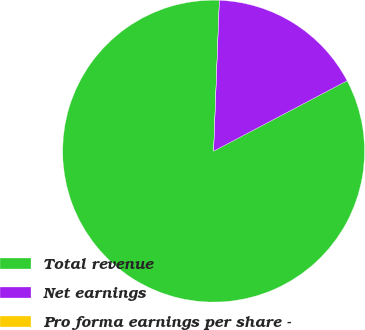Convert chart to OTSL. <chart><loc_0><loc_0><loc_500><loc_500><pie_chart><fcel>Total revenue<fcel>Net earnings<fcel>Pro forma earnings per share -<nl><fcel>83.33%<fcel>16.67%<fcel>0.0%<nl></chart> 